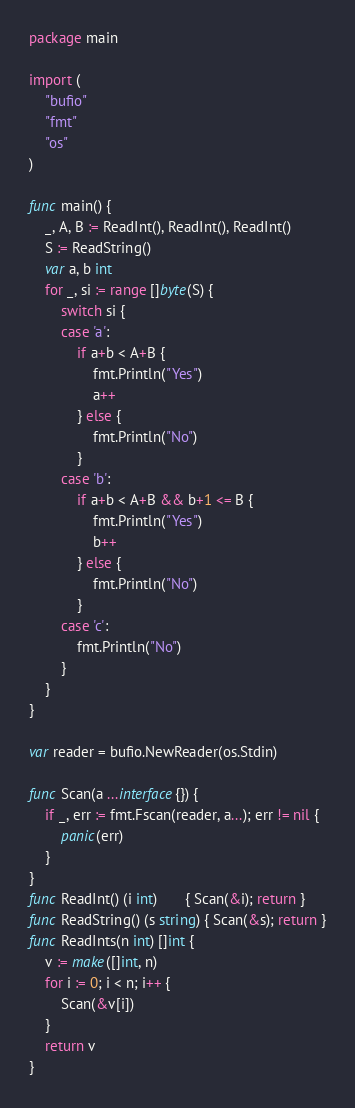Convert code to text. <code><loc_0><loc_0><loc_500><loc_500><_Go_>package main

import (
	"bufio"
	"fmt"
	"os"
)

func main() {
	_, A, B := ReadInt(), ReadInt(), ReadInt()
	S := ReadString()
	var a, b int
	for _, si := range []byte(S) {
		switch si {
		case 'a':
			if a+b < A+B {
				fmt.Println("Yes")
				a++
			} else {
				fmt.Println("No")
			}
		case 'b':
			if a+b < A+B && b+1 <= B {
				fmt.Println("Yes")
				b++
			} else {
				fmt.Println("No")
			}
		case 'c':
			fmt.Println("No")
		}
	}
}

var reader = bufio.NewReader(os.Stdin)

func Scan(a ...interface{}) {
	if _, err := fmt.Fscan(reader, a...); err != nil {
		panic(err)
	}
}
func ReadInt() (i int)       { Scan(&i); return }
func ReadString() (s string) { Scan(&s); return }
func ReadInts(n int) []int {
	v := make([]int, n)
	for i := 0; i < n; i++ {
		Scan(&v[i])
	}
	return v
}
</code> 